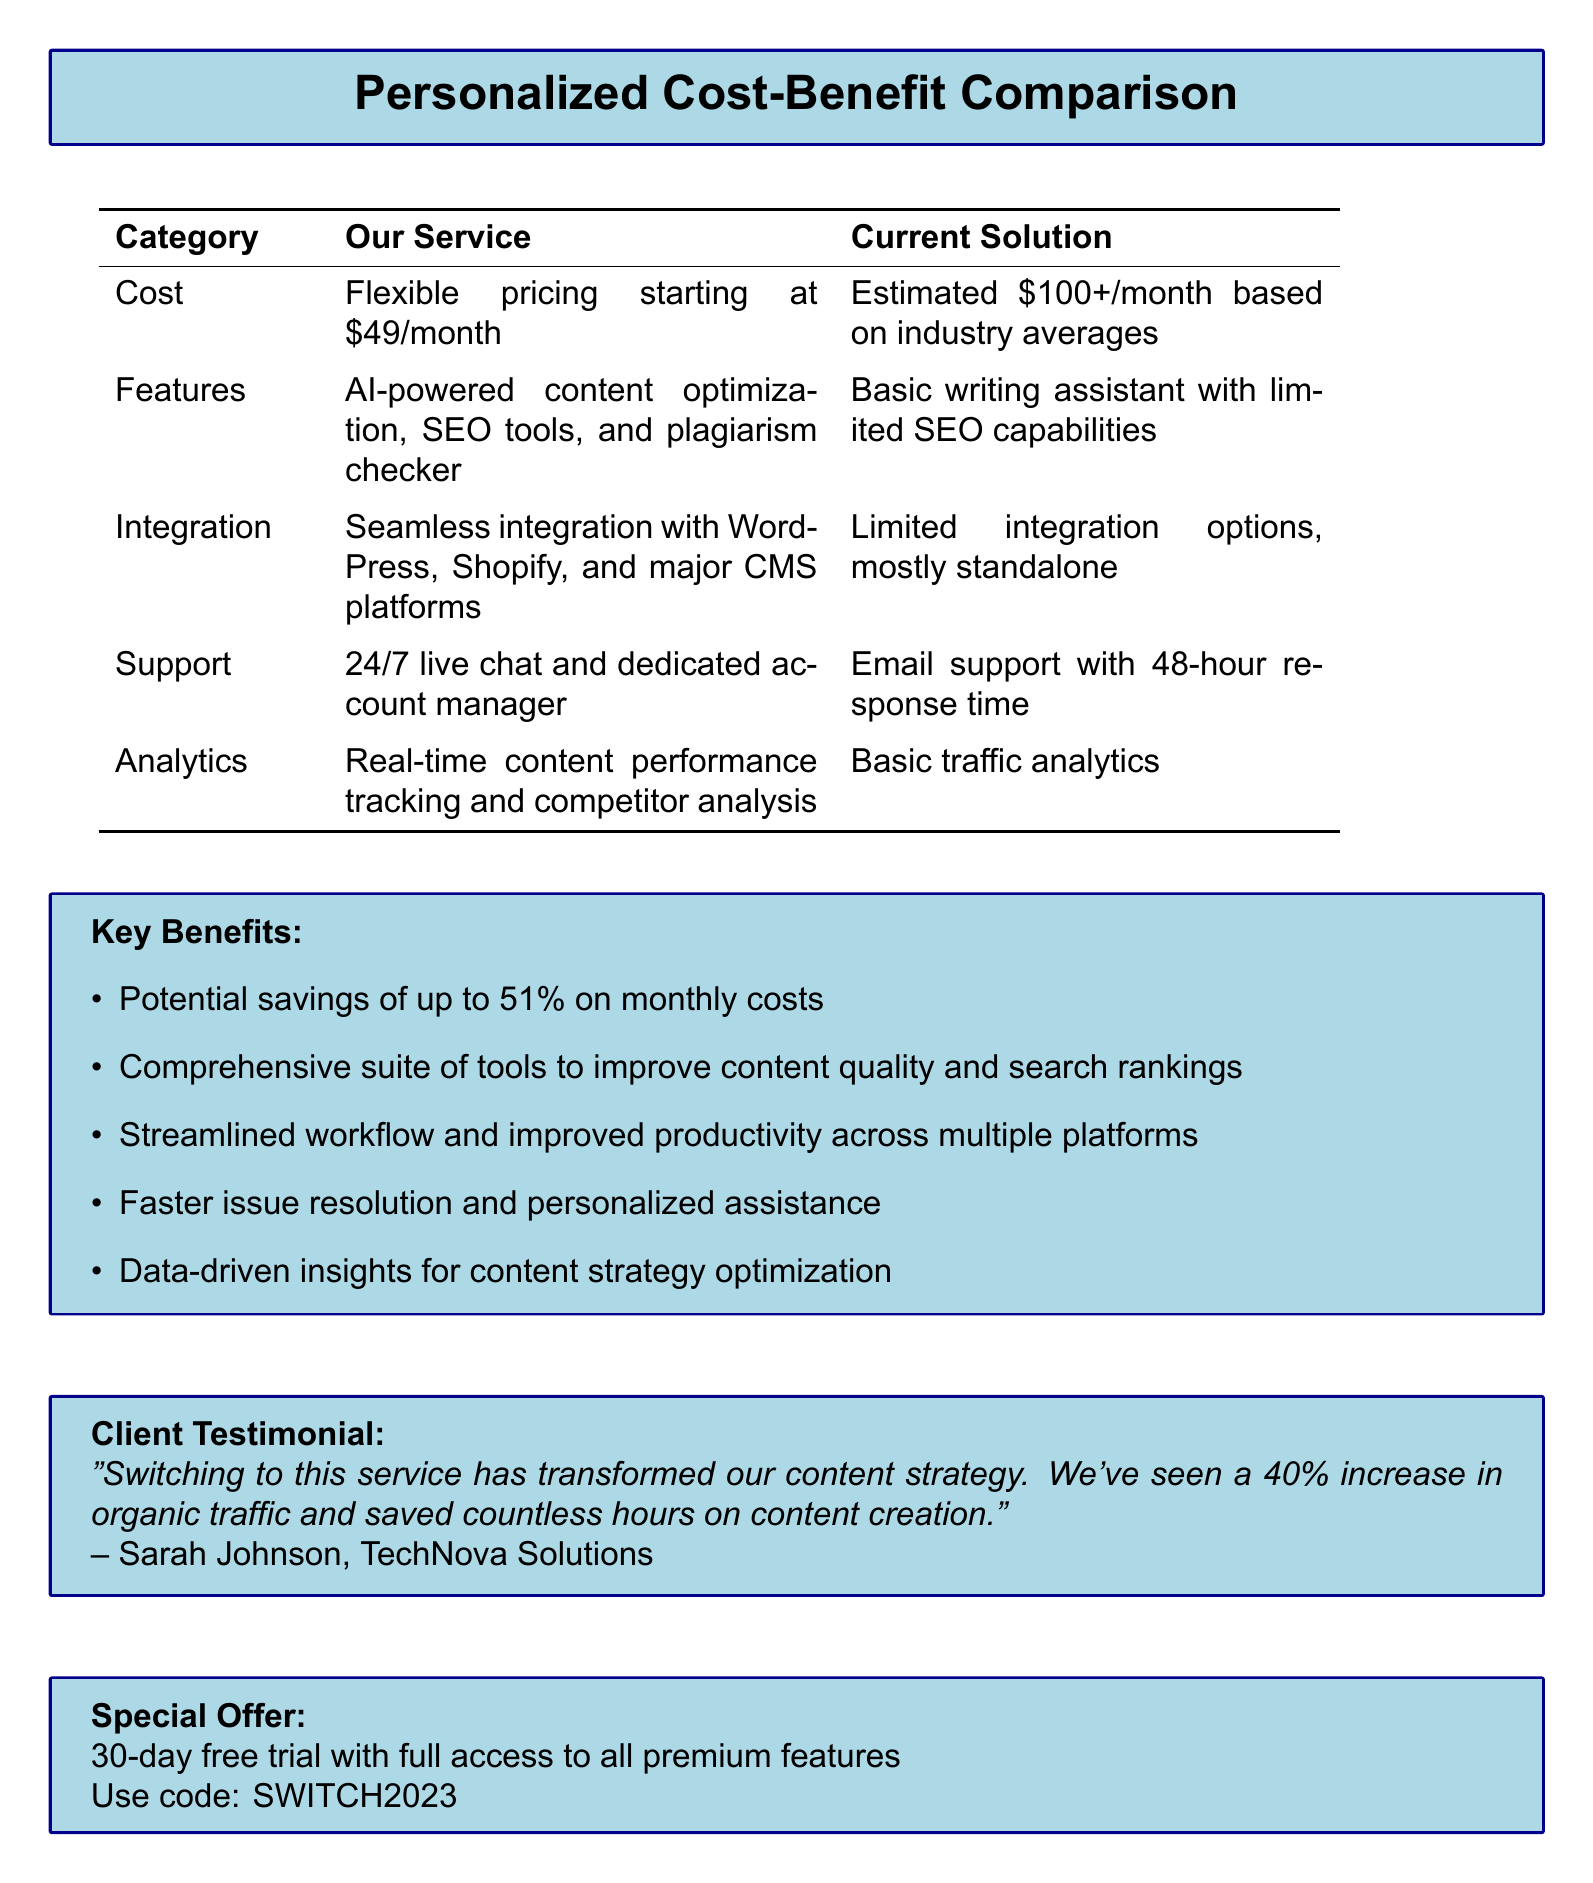What is the starting price of our service? The document states that our service has flexible pricing starting at $49/month.
Answer: $49/month What is the current estimated monthly cost for the current solution? According to the document, the estimated cost for the current solution is $100+/month.
Answer: $100+/month What percentage of savings can be achieved with our service? The document mentions potential savings of up to 51% on monthly costs.
Answer: 51% What support options does our service provide? The document lists our service as providing 24/7 live chat and a dedicated account manager, while the current solution offers email support.
Answer: 24/7 live chat and dedicated account manager What analytics capabilities does our service offer? The document indicates that our service provides real-time content performance tracking and competitor analysis, compared to basic traffic analytics in the current solution.
Answer: Real-time content performance tracking and competitor analysis Who provided the client testimonial? The document includes a testimonial from Sarah Johnson of TechNova Solutions.
Answer: Sarah Johnson, TechNova Solutions What special offer is available for new clients? The document describes a 30-day free trial with full access to all premium features as the special offer.
Answer: 30-day free trial What tools does our service include that the current solution lacks? The document specifies that our service includes AI-powered content optimization, SEO tools, and a plagiarism checker, while the current solution has limited SEO capabilities.
Answer: AI-powered content optimization, SEO tools, and plagiarism checker How can clients access the special offer? Clients can use the code SWITCH2023 to access the special offer.
Answer: SWITCH2023 